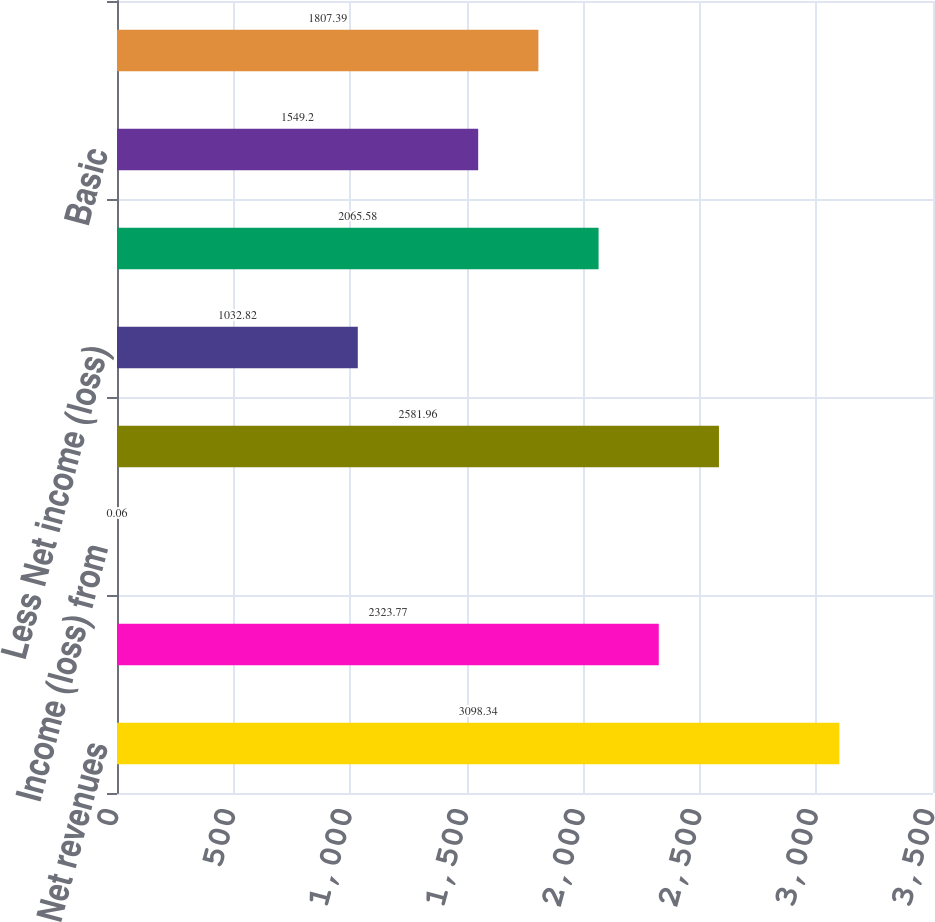Convert chart to OTSL. <chart><loc_0><loc_0><loc_500><loc_500><bar_chart><fcel>Net revenues<fcel>Income from continuing<fcel>Income (loss) from<fcel>Net income<fcel>Less Net income (loss)<fcel>Net income attributable to<fcel>Basic<fcel>Diluted<nl><fcel>3098.34<fcel>2323.77<fcel>0.06<fcel>2581.96<fcel>1032.82<fcel>2065.58<fcel>1549.2<fcel>1807.39<nl></chart> 